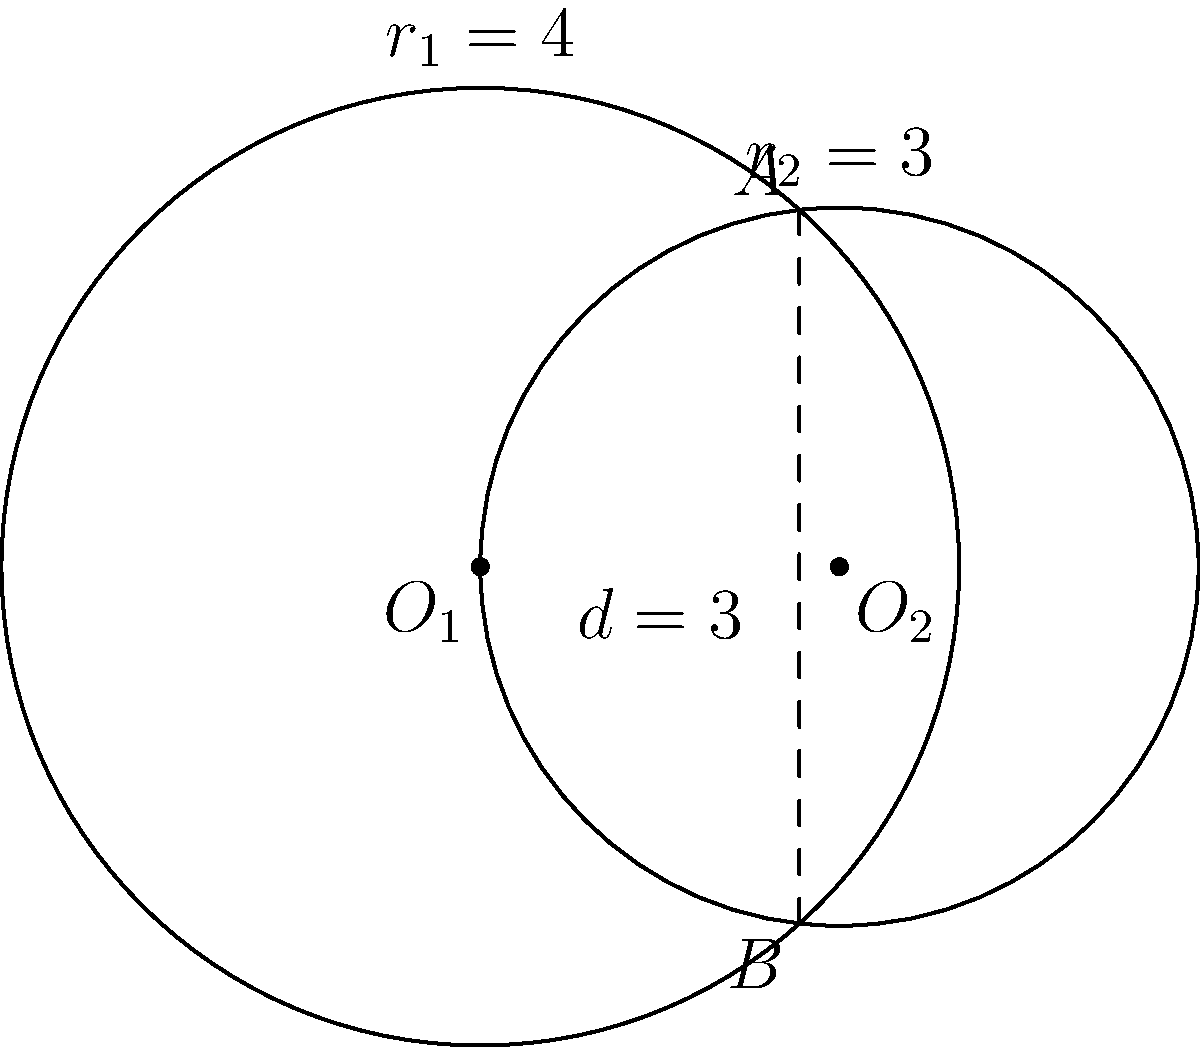In a software application for analyzing geometric shapes in European architectural designs, you need to calculate the area of overlap between two circular elements. Given two circles with centers $O_1(0,0)$ and $O_2(3,0)$, and radii $r_1 = 4$ and $r_2 = 3$ respectively, determine the area of the overlapping region. Round your answer to two decimal places and express it in square units. To calculate the area of overlap between two circles, we'll follow these steps:

1. Calculate the distance $d$ between the centers:
   $d = 3$ (given in the diagram)

2. Check if the circles intersect:
   $r_1 + r_2 > d > |r_1 - r_2|$
   $7 > 3 > 1$, so they intersect.

3. Calculate the central angles $\theta_1$ and $\theta_2$:
   $\theta_1 = 2 \arccos(\frac{d^2 + r_1^2 - r_2^2}{2dr_1})$
   $\theta_1 = 2 \arccos(\frac{3^2 + 4^2 - 3^2}{2 \cdot 3 \cdot 4}) = 2 \arccos(\frac{25}{24}) \approx 1.2490$ radians

   $\theta_2 = 2 \arccos(\frac{d^2 + r_2^2 - r_1^2}{2dr_2})$
   $\theta_2 = 2 \arccos(\frac{3^2 + 3^2 - 4^2}{2 \cdot 3 \cdot 3}) = 2 \arccos(-\frac{1}{6}) \approx 2.7286$ radians

4. Calculate the area of overlap:
   $A = \frac{1}{2}r_1^2(\theta_1 - \sin\theta_1) + \frac{1}{2}r_2^2(\theta_2 - \sin\theta_2)$
   $A = \frac{1}{2} \cdot 4^2 \cdot (1.2490 - \sin(1.2490)) + \frac{1}{2} \cdot 3^2 \cdot (2.7286 - \sin(2.7286))$
   $A \approx 4.4934 + 5.0539 = 9.5473$ square units

5. Round to two decimal places:
   $A \approx 9.55$ square units
Answer: 9.55 square units 